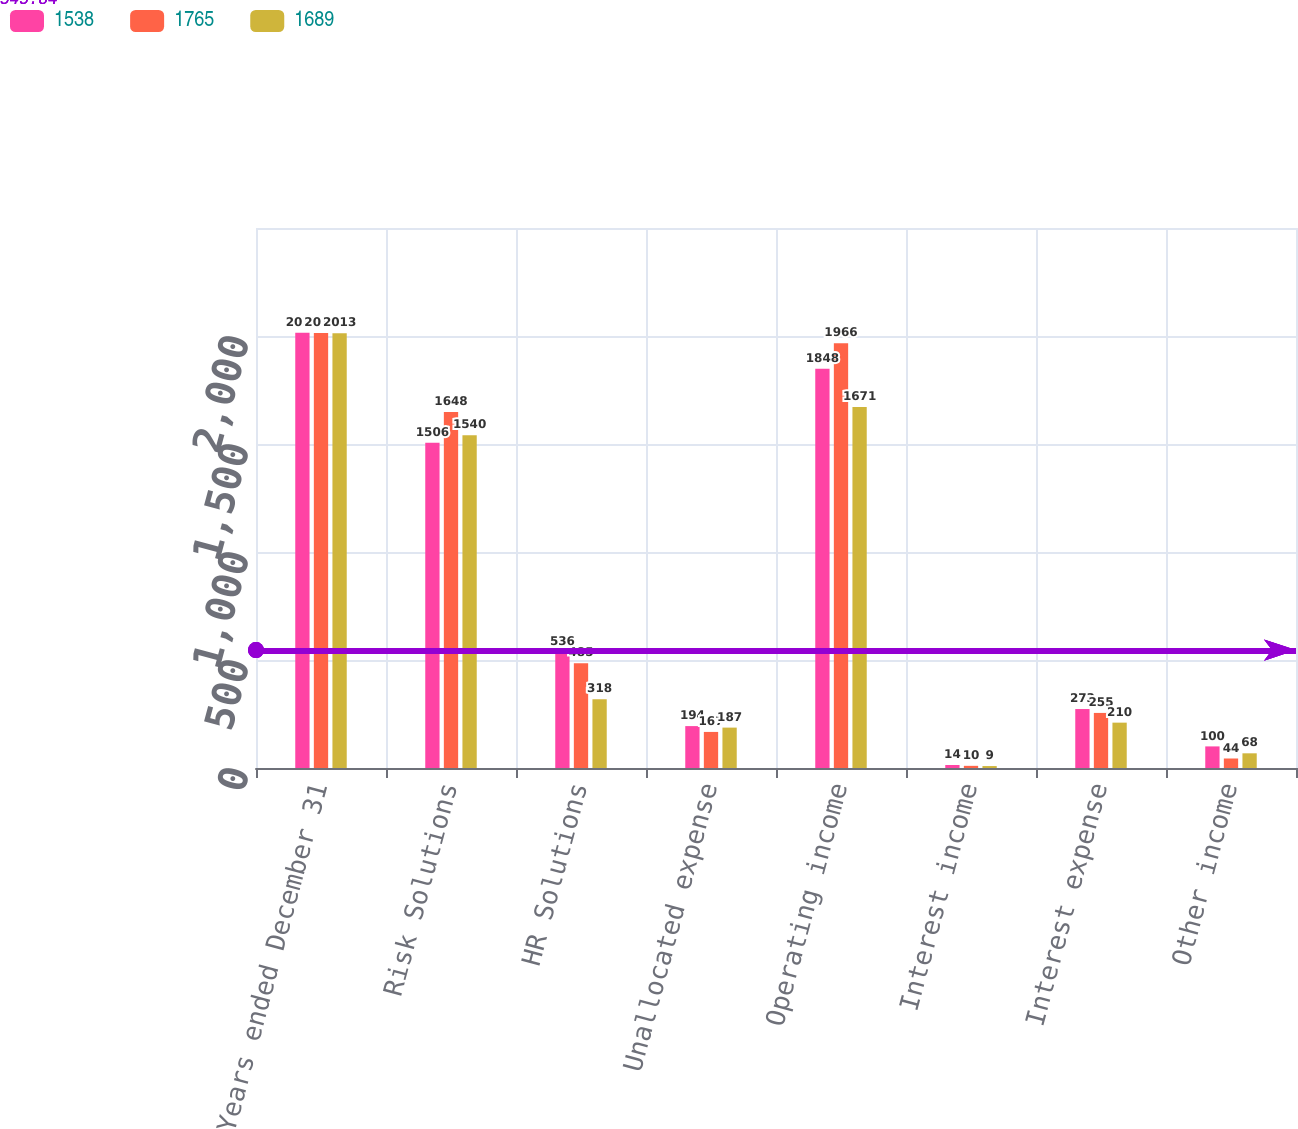Convert chart. <chart><loc_0><loc_0><loc_500><loc_500><stacked_bar_chart><ecel><fcel>Years ended December 31<fcel>Risk Solutions<fcel>HR Solutions<fcel>Unallocated expense<fcel>Operating income<fcel>Interest income<fcel>Interest expense<fcel>Other income<nl><fcel>1538<fcel>2015<fcel>1506<fcel>536<fcel>194<fcel>1848<fcel>14<fcel>273<fcel>100<nl><fcel>1765<fcel>2014<fcel>1648<fcel>485<fcel>167<fcel>1966<fcel>10<fcel>255<fcel>44<nl><fcel>1689<fcel>2013<fcel>1540<fcel>318<fcel>187<fcel>1671<fcel>9<fcel>210<fcel>68<nl></chart> 